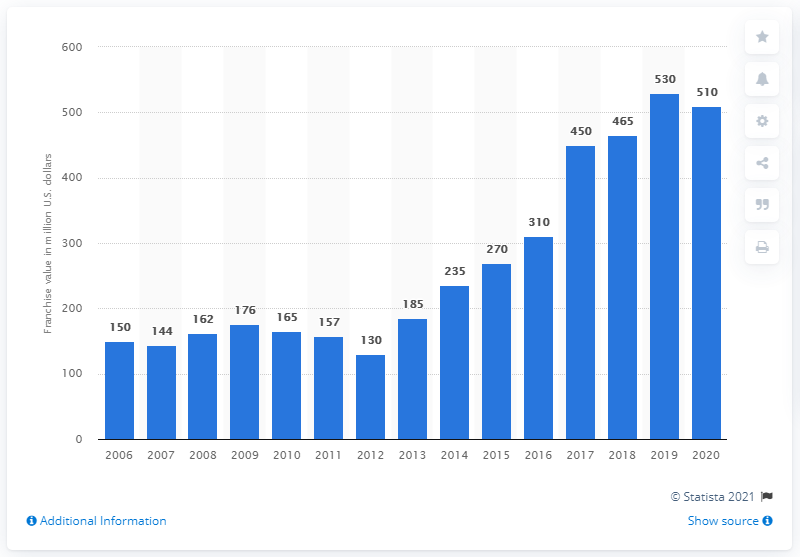Highlight a few significant elements in this photo. In 2020, the value of the St. Louis Blues franchise was approximately $510 million. 